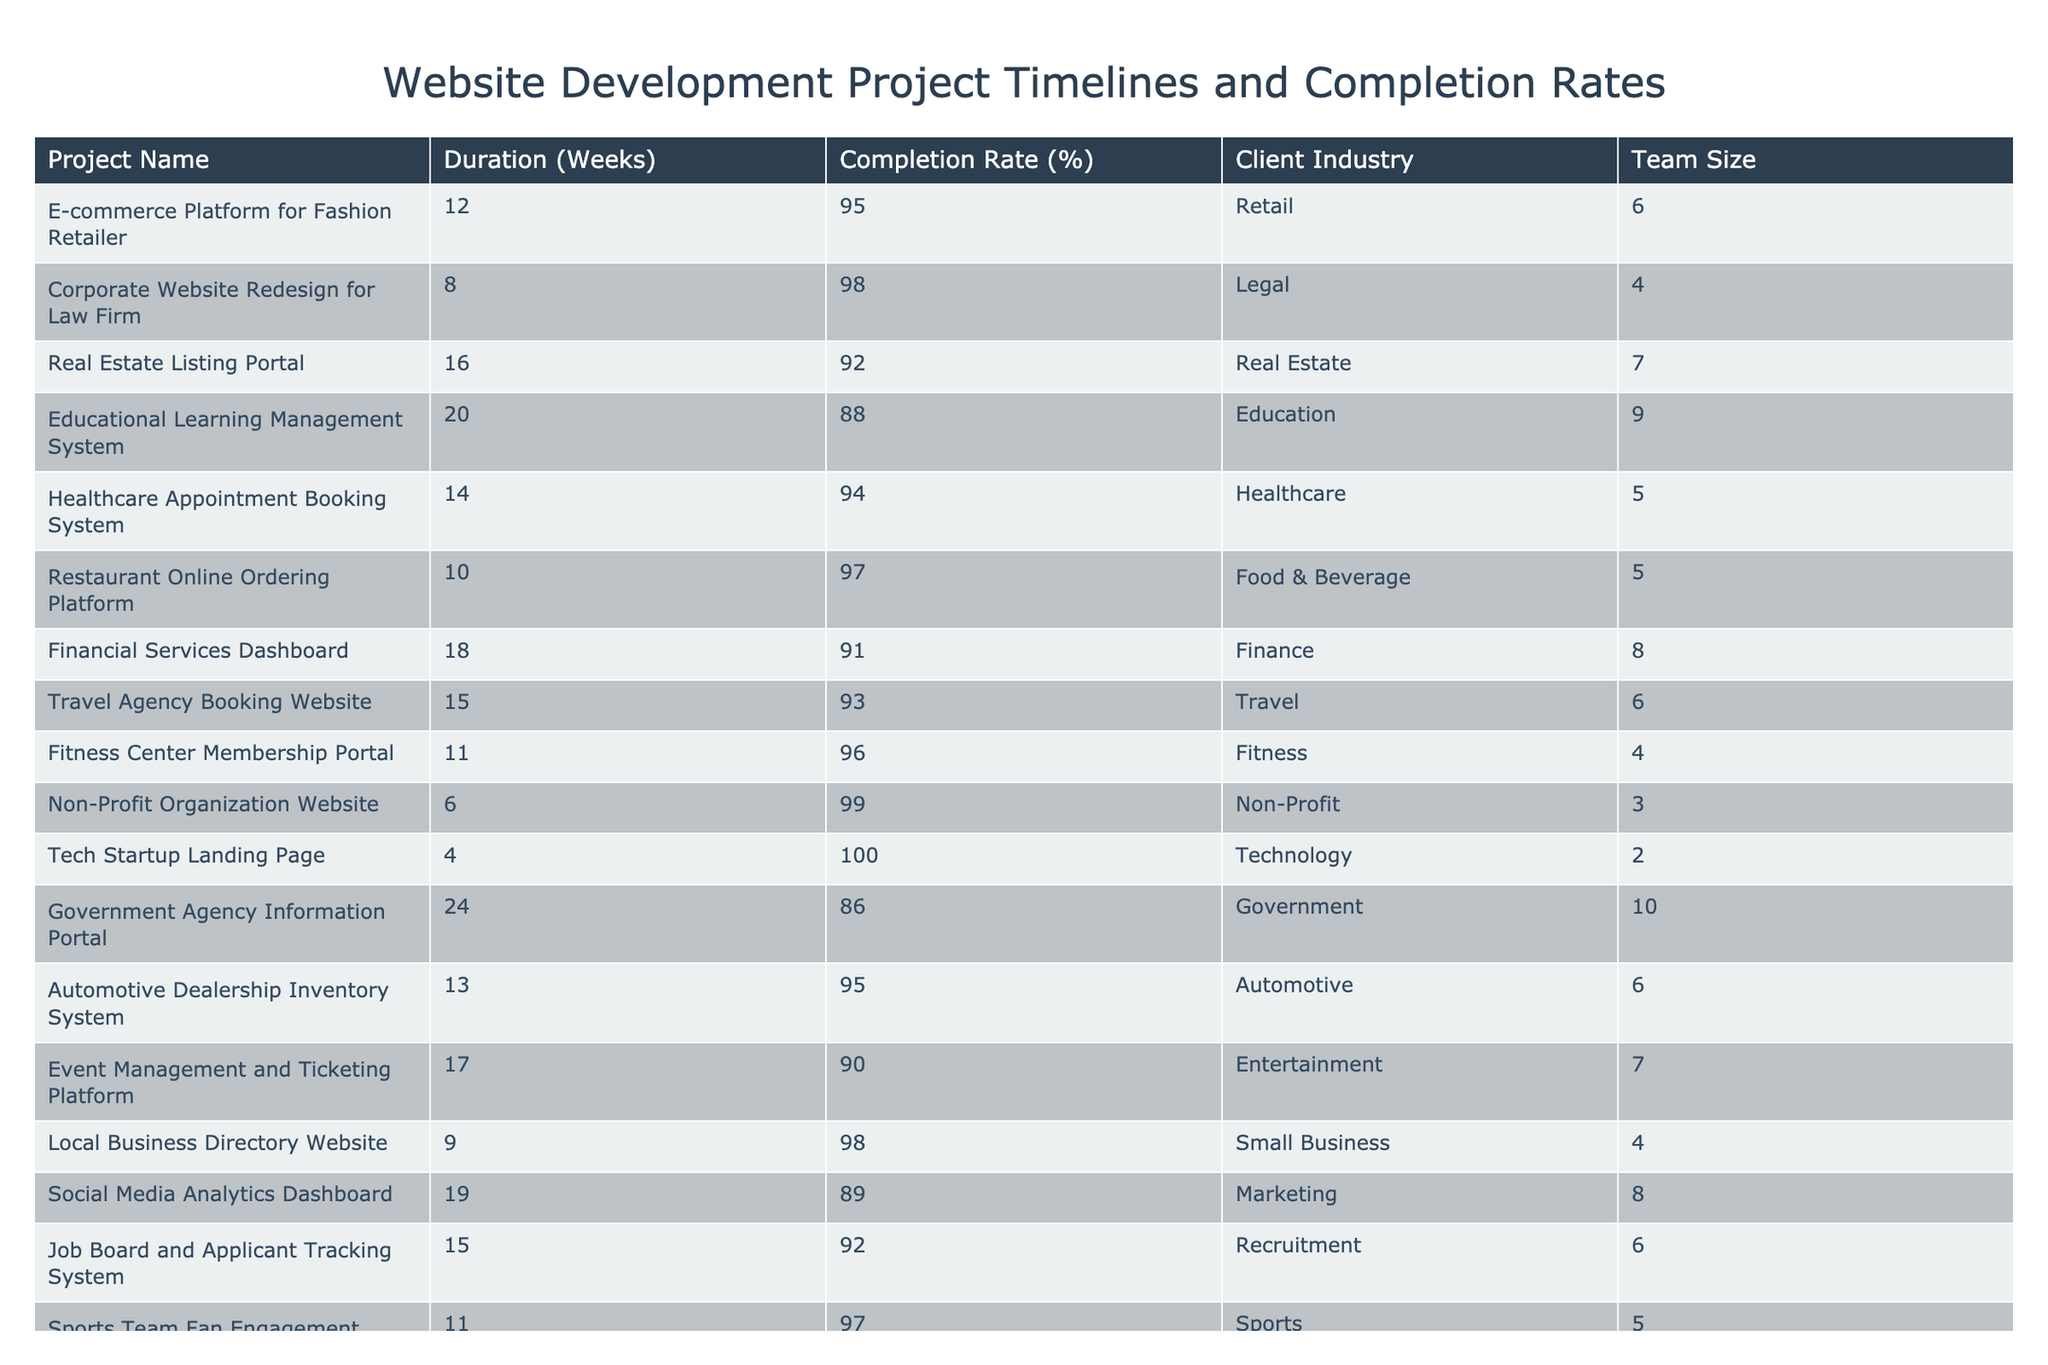What is the completion rate of the "Corporate Website Redesign for Law Firm"? The table lists the completion rates for each project. By locating the row for the "Corporate Website Redesign for Law Firm," we find that its completion rate is 98%.
Answer: 98% Which project has the longest duration? To identify the longest duration, we compare the 'Duration (Weeks)' values for all projects. The longest duration is 24 weeks for the "Government Agency Information Portal."
Answer: 24 weeks Is the completion rate for the "E-commerce Platform for Fashion Retailer" greater than 90%? Checking the completion rate for the "E-commerce Platform for Fashion Retailer," we see it is 95%, which is indeed greater than 90%.
Answer: Yes What is the average completion rate of all projects listed? We sum the completion rates (95 + 98 + 92 + 88 + 94 + 97 + 91 + 93 + 96 + 99 + 100 + 86 + 95 + 90 + 98 + 89 + 92 + 97 + 94 + 99 = 1848) and divide by the total number of projects (20), which gives us an average completion rate of 1848/20 = 92.4%.
Answer: 92.4% How many projects exceed a duration of 15 weeks? By examining the 'Duration (Weeks)' column, we count the projects with a duration greater than 15 weeks. These are the "Real Estate Listing Portal," "Educational Learning Management System," "Financial Services Dashboard," "Travel Agency Booking Website," and "Government Agency Information Portal," totaling 5 projects.
Answer: 5 Which project has the smallest team size and what is it? We look through the 'Team Size' column and find that the "Tech Startup Landing Page" has the smallest team size of 2 members.
Answer: 2 Are there any projects with a completion rate of 100%? We check the completion rates in the table and find that the "Tech Startup Landing Page" has a completion rate of 100%.
Answer: Yes What is the difference in completion rates between the project with the highest and lowest completion rates? The highest completion rate is 100% (from the "Tech Startup Landing Page") and the lowest is 86% (from the "Government Agency Information Portal"), so the difference is 100 - 86 = 14%.
Answer: 14% Which industry has the project with the shortest duration and what is the project's name? Scanning the 'Duration (Weeks)' column, the project with the shortest duration of 4 weeks belongs to the Technology industry, specifically the "Tech Startup Landing Page."
Answer: Tech Startup Landing Page What is the total duration in weeks for projects in the Education and Healthcare industries? We sum the durations for those industries: Education (20 weeks) + Healthcare (14 weeks) = 34 weeks total for both industries.
Answer: 34 weeks 